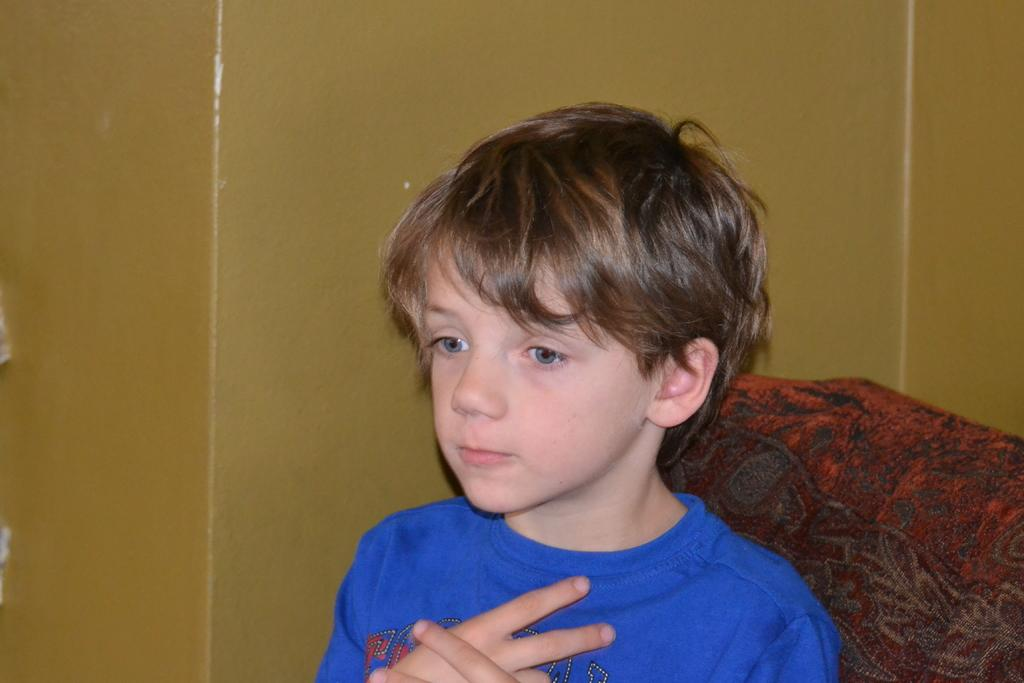What can be seen in the background of the image? There is a wall in the background of the image. Who is present in the image? There is a boy in the image. What is the boy wearing? The boy is wearing a blue t-shirt. Can you describe any furniture in the image? There appears to be a chair on the right side of the image. Are there any ants crawling on the boy's blue t-shirt in the image? There is no indication of ants or any other insects on the boy's blue t-shirt in the image. 